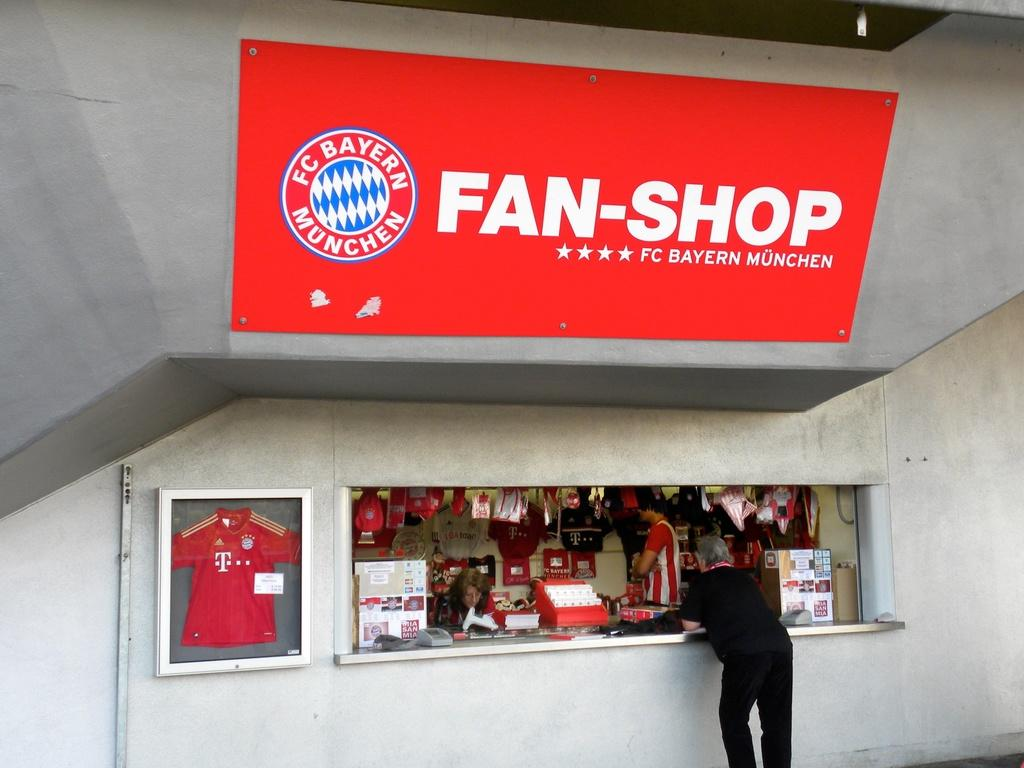<image>
Share a concise interpretation of the image provided. A man stands at the counter of the FC Bayern Munchen Fan-Shop. 